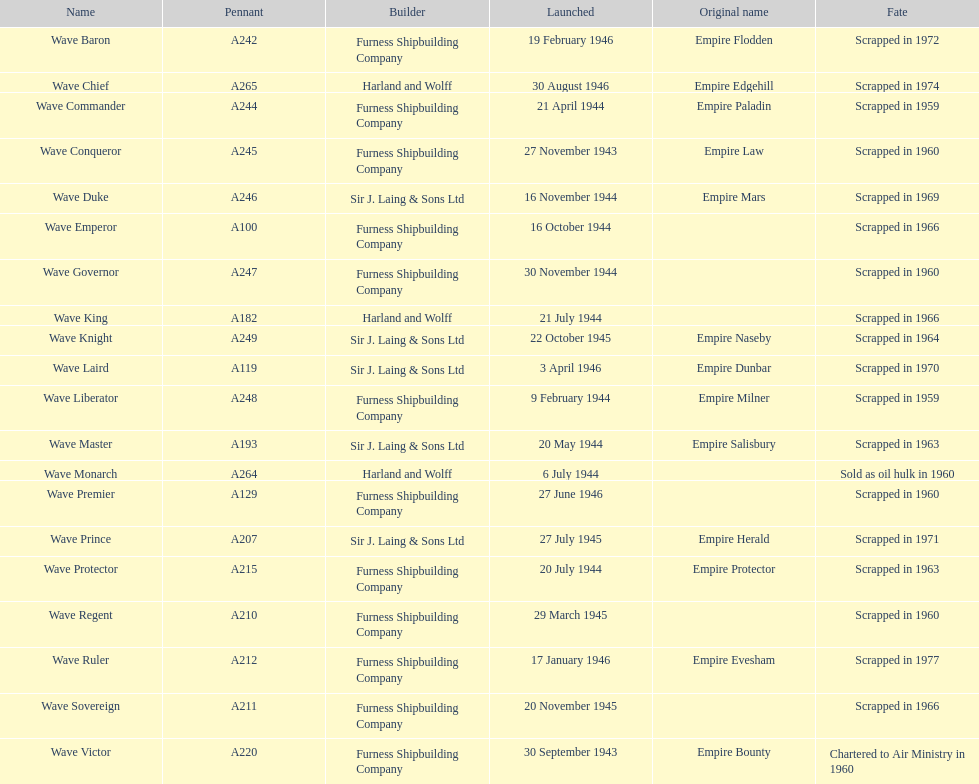What is the name of the last ship that was scrapped? Wave Ruler. 